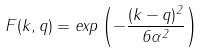<formula> <loc_0><loc_0><loc_500><loc_500>F ( { k } , { q } ) = e x p \left ( - \frac { ( { k } - { q } ) ^ { 2 } } { 6 \alpha ^ { 2 } } \right )</formula> 